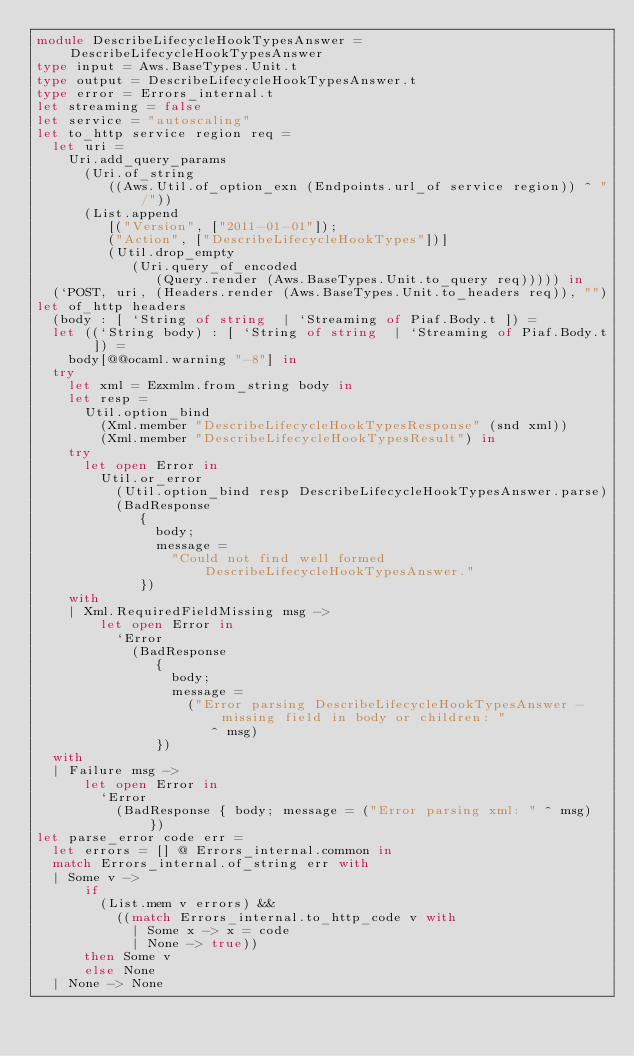<code> <loc_0><loc_0><loc_500><loc_500><_OCaml_>module DescribeLifecycleHookTypesAnswer = DescribeLifecycleHookTypesAnswer
type input = Aws.BaseTypes.Unit.t
type output = DescribeLifecycleHookTypesAnswer.t
type error = Errors_internal.t
let streaming = false
let service = "autoscaling"
let to_http service region req =
  let uri =
    Uri.add_query_params
      (Uri.of_string
         ((Aws.Util.of_option_exn (Endpoints.url_of service region)) ^ "/"))
      (List.append
         [("Version", ["2011-01-01"]);
         ("Action", ["DescribeLifecycleHookTypes"])]
         (Util.drop_empty
            (Uri.query_of_encoded
               (Query.render (Aws.BaseTypes.Unit.to_query req))))) in
  (`POST, uri, (Headers.render (Aws.BaseTypes.Unit.to_headers req)), "")
let of_http headers
  (body : [ `String of string  | `Streaming of Piaf.Body.t ]) =
  let ((`String body) : [ `String of string  | `Streaming of Piaf.Body.t ]) =
    body[@@ocaml.warning "-8"] in
  try
    let xml = Ezxmlm.from_string body in
    let resp =
      Util.option_bind
        (Xml.member "DescribeLifecycleHookTypesResponse" (snd xml))
        (Xml.member "DescribeLifecycleHookTypesResult") in
    try
      let open Error in
        Util.or_error
          (Util.option_bind resp DescribeLifecycleHookTypesAnswer.parse)
          (BadResponse
             {
               body;
               message =
                 "Could not find well formed DescribeLifecycleHookTypesAnswer."
             })
    with
    | Xml.RequiredFieldMissing msg ->
        let open Error in
          `Error
            (BadResponse
               {
                 body;
                 message =
                   ("Error parsing DescribeLifecycleHookTypesAnswer - missing field in body or children: "
                      ^ msg)
               })
  with
  | Failure msg ->
      let open Error in
        `Error
          (BadResponse { body; message = ("Error parsing xml: " ^ msg) })
let parse_error code err =
  let errors = [] @ Errors_internal.common in
  match Errors_internal.of_string err with
  | Some v ->
      if
        (List.mem v errors) &&
          ((match Errors_internal.to_http_code v with
            | Some x -> x = code
            | None -> true))
      then Some v
      else None
  | None -> None</code> 